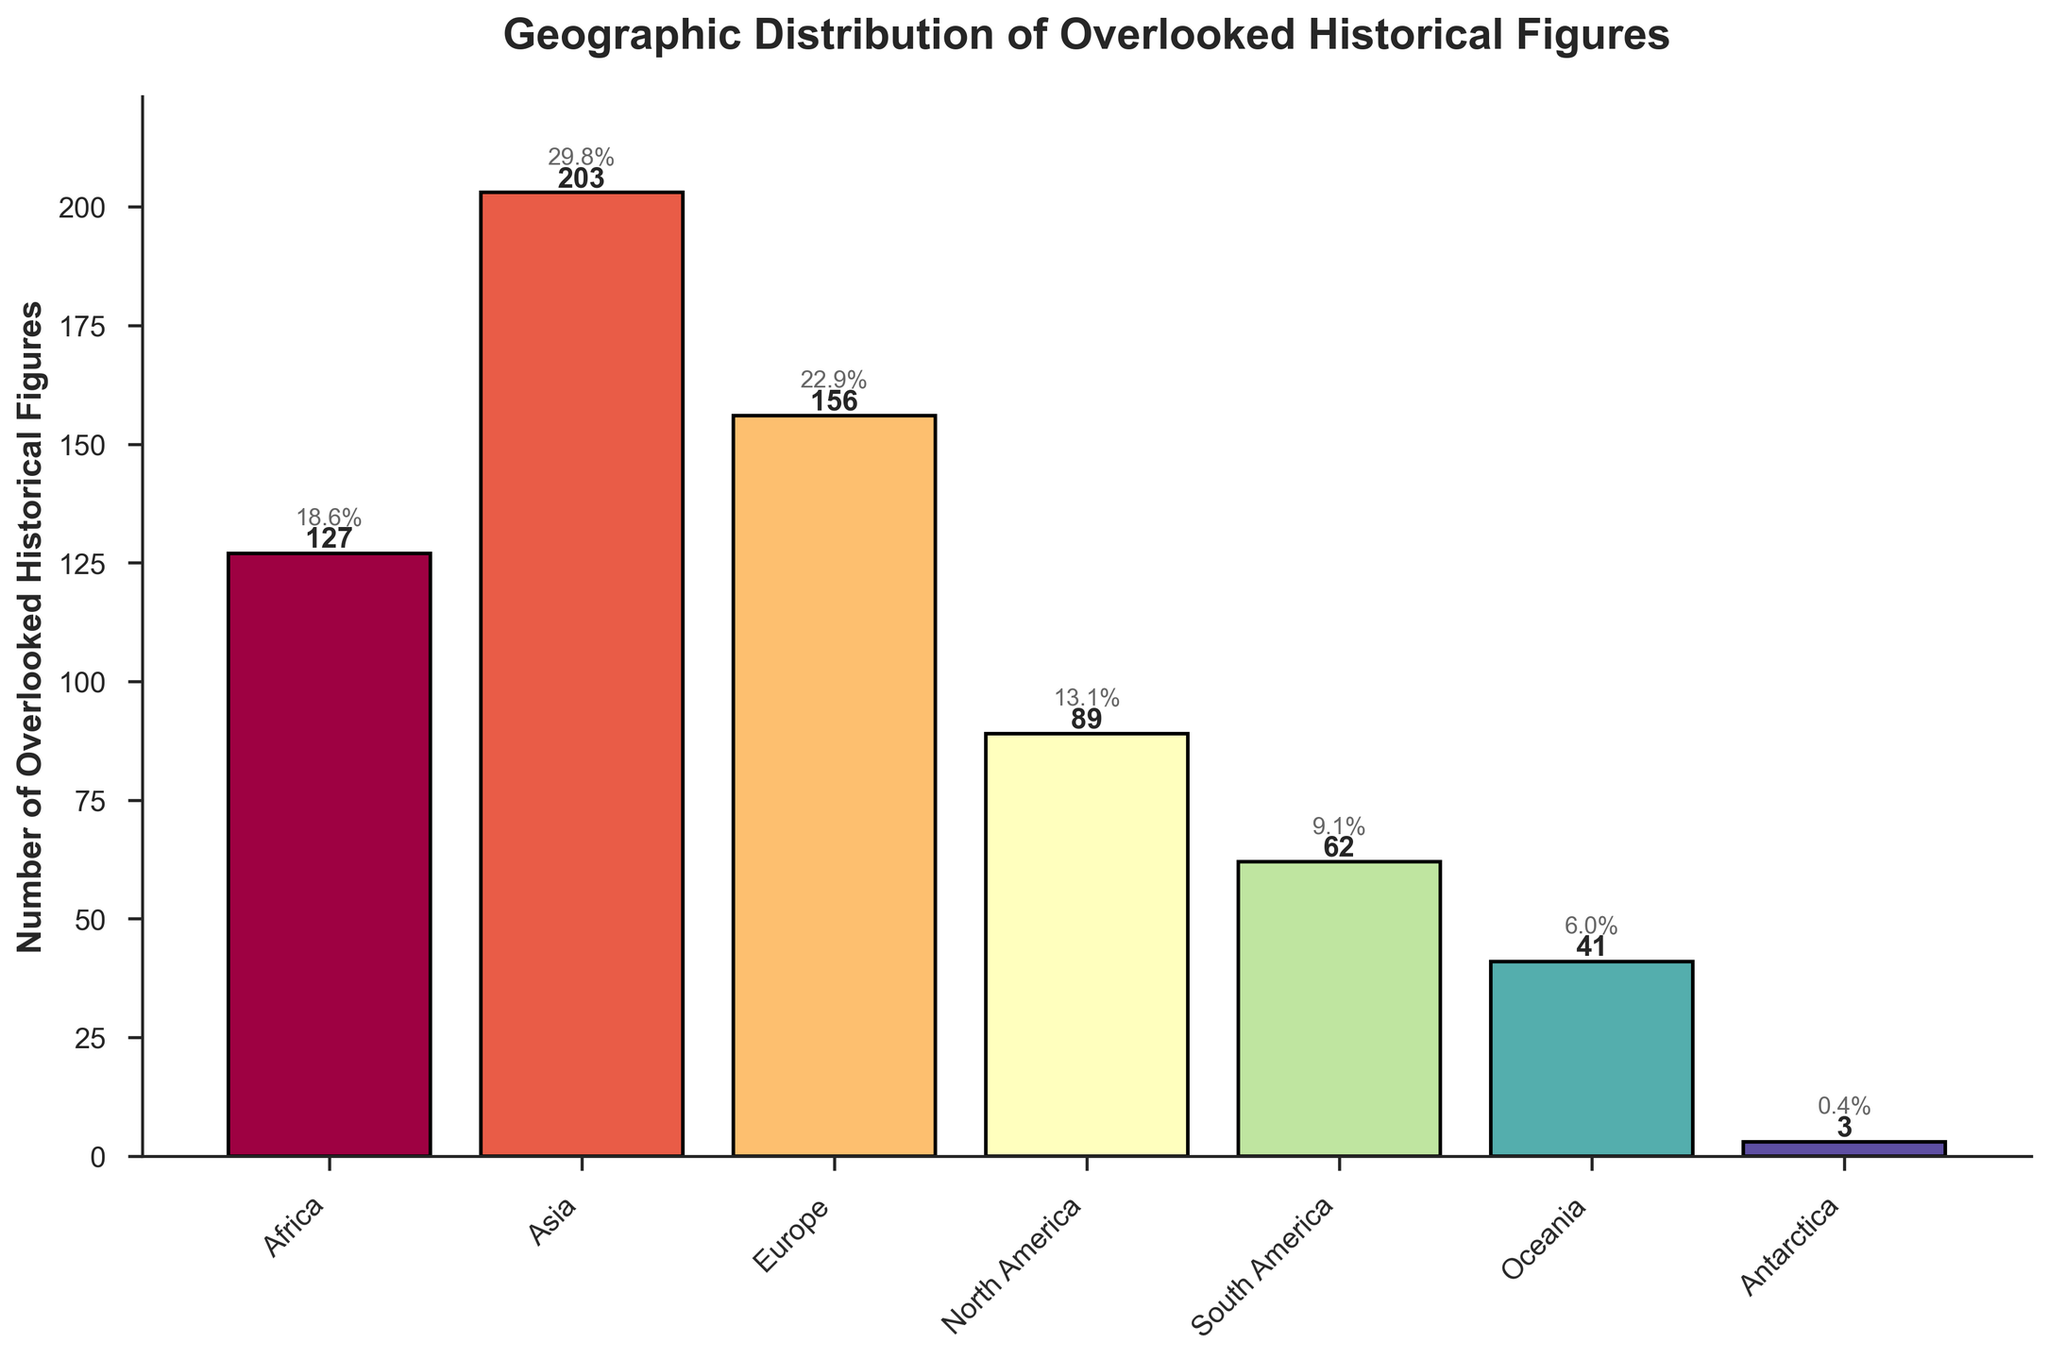Which continent has the highest number of overlooked historical figures? The bar representing Asia is the tallest, indicating that Asia has the highest number (203) of overlooked historical figures.
Answer: Asia How many more overlooked historical figures are there in Europe compared to North America? To find the difference, subtract the number of overlooked historical figures in North America (89) from the number in Europe (156): 156 - 89 = 67.
Answer: 67 Which continents have fewer than 50 overlooked historical figures? The bars corresponding to Oceania and Antarctica are below the 50 mark. Oceania has 41, and Antarctica has 3 overlooked historical figures.
Answer: Oceania, Antarctica What percentage of the total overlooked historical figures does Africa represent? Calculate the total number of overlooked historical figures by summing all values: 127 + 203 + 156 + 89 + 62 + 41 + 3 = 681. Then, the percentage of Africa is (127 / 681) * 100 ≈ 18.6%.
Answer: 18.6% Which continent has the smallest number of overlooked historical figures, and how many? The bar corresponding to Antarctica is the shortest, indicating that Antarctica has the smallest number of overlooked historical figures (3).
Answer: Antarctica, 3 What is the combined total of overlooked historical figures in South America and Oceania? Add the number of overlooked historical figures in South America (62) and Oceania (41): 62 + 41 = 103.
Answer: 103 How does the number of overlooked historical figures in Asia compare to the sum of Europe and Africa? Calculate the sum of overlooked historical figures in Europe (156) and Africa (127): 156 + 127 = 283. Then compare it to Asia (203): 203 < 283.
Answer: Less than Which continent surpasses 150 overlooked historical figures? Both Asia and Europe have bars exceeding the 150 mark, with figures of 203 and 156, respectively.
Answer: Asia, Europe What is the difference between the continents with the highest and lowest number of overlooked historical figures? Subtract the number of overlooked historical figures in Antarctica (3) from Asia (203): 203 - 3 = 200.
Answer: 200 What is the average number of overlooked historical figures per continent? Calculate the total number of overlooked historical figures: 681. Then, divide this total by the number of continents (7): 681 / 7 ≈ 97.3.
Answer: 97.3 